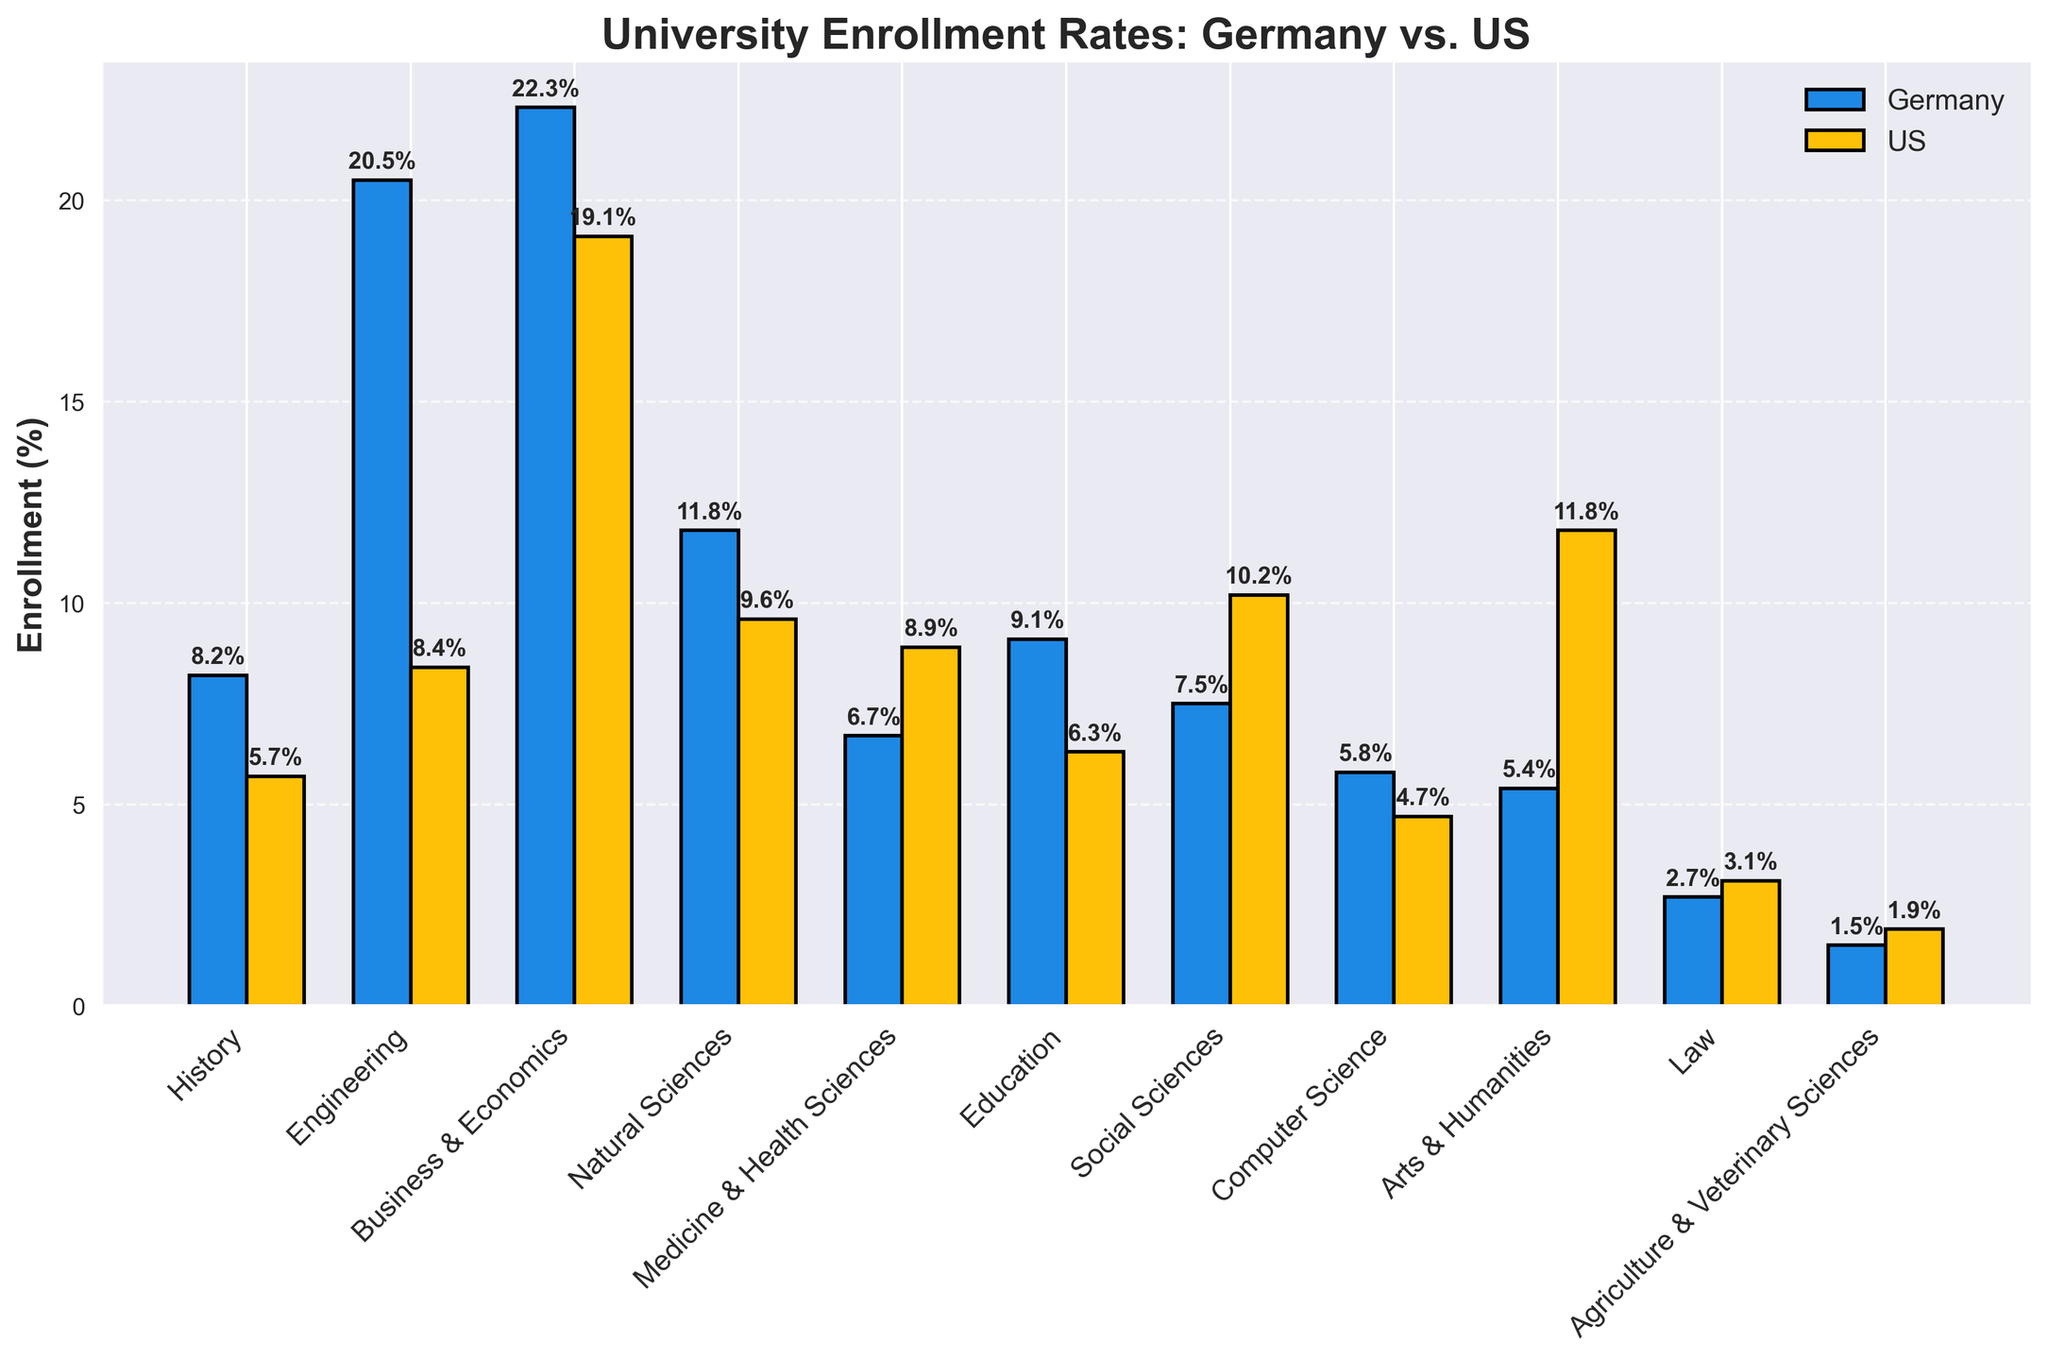Which field of study has a higher university enrollment rate in Germany compared to the US? By inspecting each pair of bars for each field of study, we see that the fields with higher enrollment rates in Germany compared to the US are History, Engineering, Business & Economics, Natural Sciences, Education, and Computer Science.
Answer: History, Engineering, Business & Economics, Natural Sciences, Education, and Computer Science What is the enrollment difference in Business & Economics between Germany and the US? The bar for Business & Economics in Germany is labeled 22.3% and in the US is labeled 19.1%. The difference is calculated as 22.3% - 19.1%.
Answer: 3.2% Which field has the greatest disparity in enrollment rates between Germany and the US? By examining the height of the bars and their corresponding labels, the greatest disparity can be identified by the largest difference in percentage points between any two bars. For Arts & Humanities, the German enrollment is 5.4% and the US enrollment is 11.8%, revealing a difference of 6.4 percentage points.
Answer: Arts & Humanities Which country has a higher enrollment rate in Medicine & Health Sciences? The bar for Medicine & Health Sciences in the US is labeled 8.9%, while the bar for Germany is labeled 6.7%.
Answer: US What are the two fields with the lowest enrollment rates in Germany? By looking at the bar heights, the two fields with the short bars indicate the lowest percentages. Agriculture & Veterinary Sciences has 1.5%, and Law has 2.7%.
Answer: Agriculture & Veterinary Sciences and Law How do the enrollment rates for Engineering compare between Germany and the US? The bar for Engineering in Germany is 20.5%, while for the US, it is 8.4%. The Germany enrollment rate is significantly higher than the US.
Answer: Germany has a higher rate Which fields in the US have lower enrollment rates compared to Germany by more than 4 percentage points? By identifying fields where Germany's value exceeds the US's value by more than 4 percentage points: Engineering (20.5% - 8.4% = 12.1%), Natural Sciences (11.8% - 9.6% = 2.2%, not more than 4), Education (9.1% - 6.3% = 2.8%, not more than 4), Computer Science (5.8% - 4.7% = 1.1%, not more than 4).
Answer: Only Engineering Which country has a greater variety in spread of enrollment rates across different fields of study? By visually comparing the heights of the bars, the US has a more balanced spread with fewer extreme highs or lows compared to Germany which has notable highs in Engineering and Business & Economics, and lows in Arts & Humanities and Law.
Answer: Germany What is the combined enrollment rate for Social Sciences and Education in the US? The bar for Social Sciences in the US is labeled 10.2% and for Education, it is labeled 6.3%. Adding these two together, we get 10.2 + 6.3.
Answer: 16.5% Which field has the highest enrollment rate in Germany? By identifying the tallest bar in the Germany dataset, we see that Business & Economics has the highest enrollment rate at 22.3%.
Answer: Business & Economics 